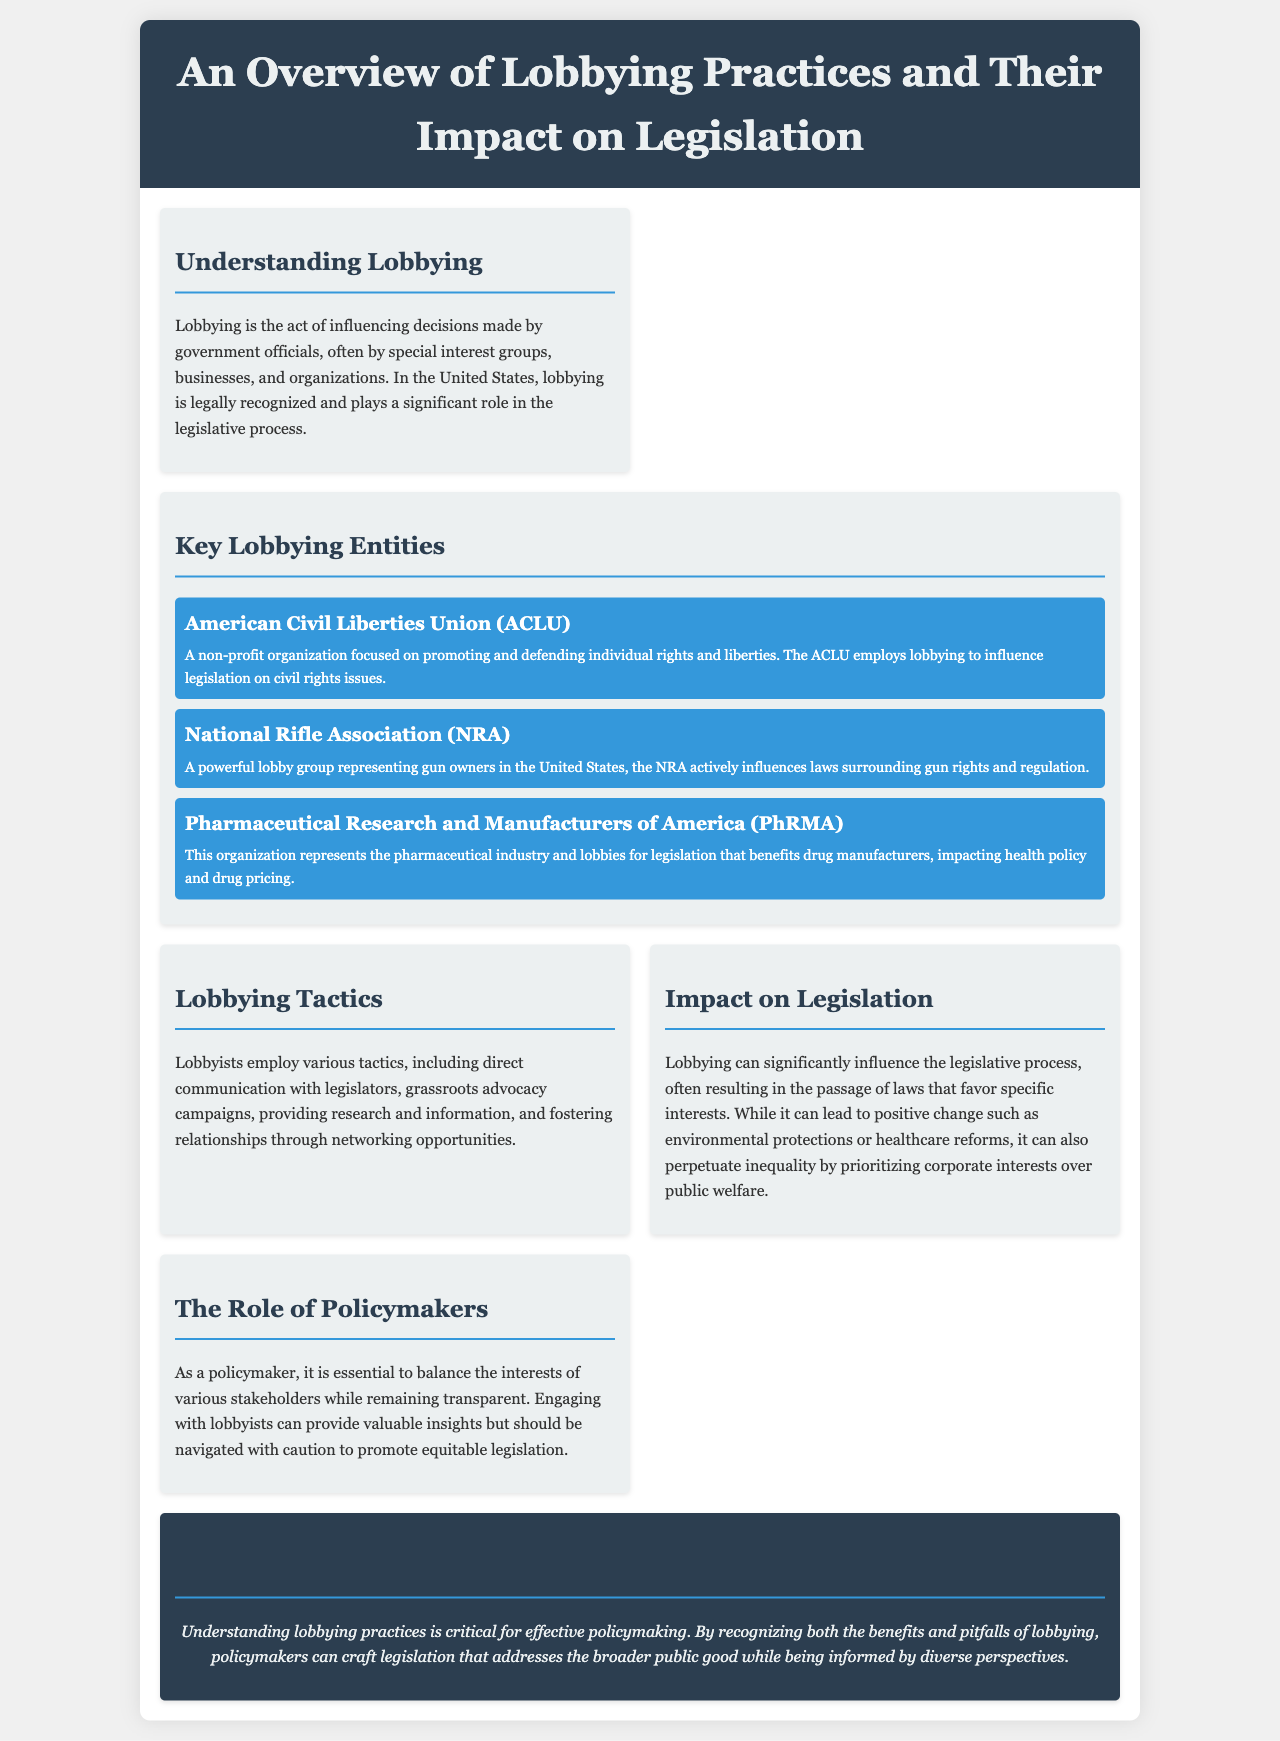what is the title of the brochure? The title is prominently displayed in the header section of the document.
Answer: An Overview of Lobbying Practices and Their Impact on Legislation who is represented by the NRA? The NRA is identified in the document as a lobby group that represents a specific group in society.
Answer: gun owners what is one tactic employed by lobbyists? The document lists several tactics lobbyists use for influencing legislation.
Answer: direct communication which organization focuses on individual rights and liberties? The document specifically mentions an organization that is focused on this area.
Answer: American Civil Liberties Union (ACLU) what is a potential negative impact of lobbying mentioned? The document discusses both positive and negative impacts of lobbying on legislation.
Answer: perpetuate inequality how many key lobbying entities are highlighted in the brochure? The document includes a section that lists the major entities involved in lobbying.
Answer: three what is emphasized as essential for policymakers in the document? It discusses the importance of transparency and stakeholder engagement.
Answer: balance interests what color is used for the conclusion section? The document utilizes a specific color scheme for different sections.
Answer: dark blue 